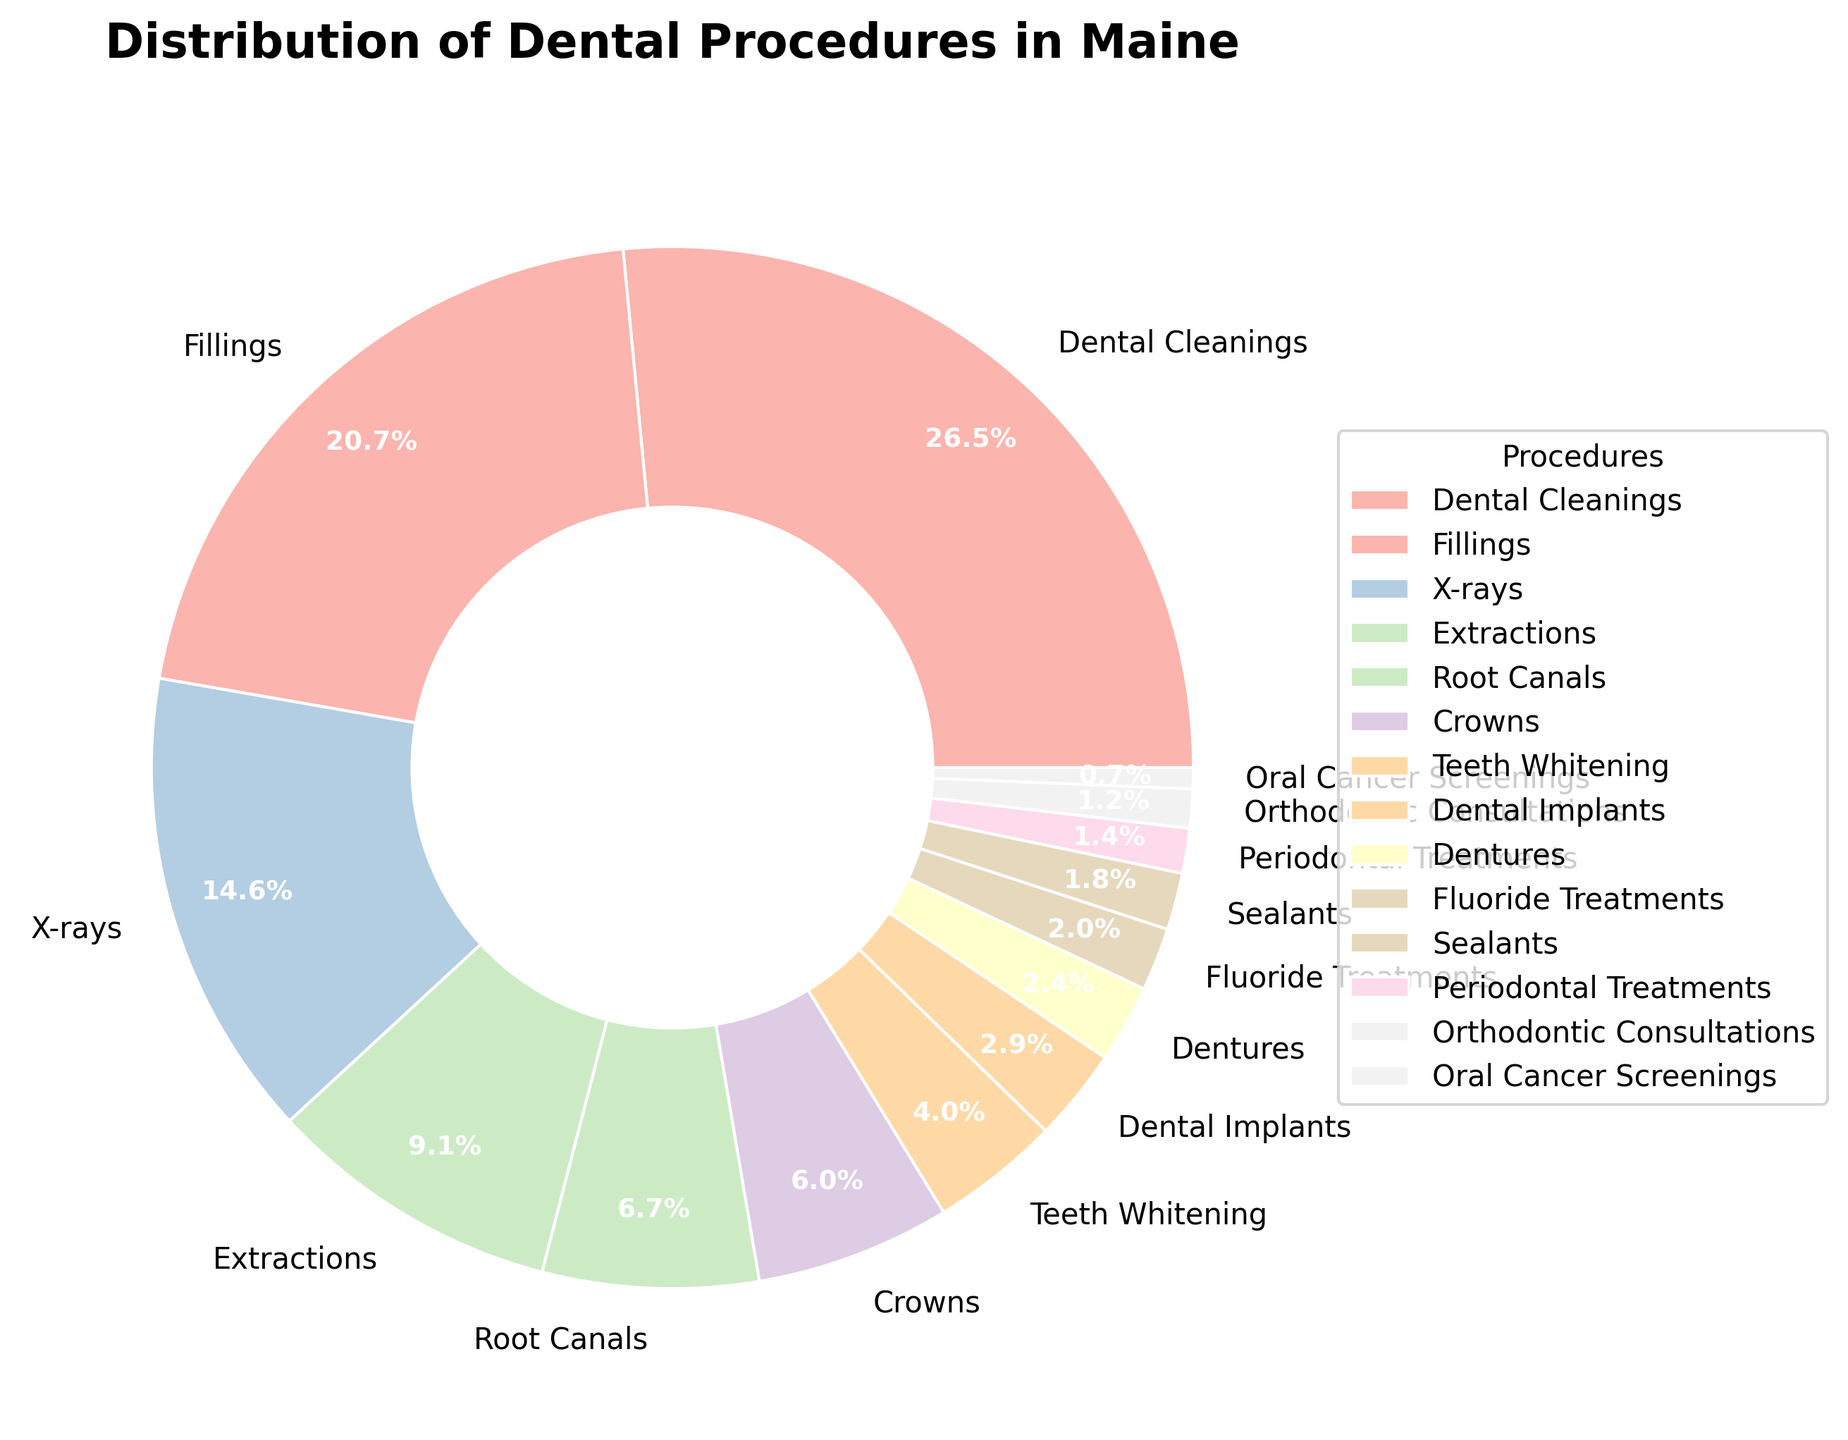What's the most common dental procedure in Maine? The figure shows the distributions of different dental procedures in Maine based on their percentages. By looking at the wedge with the largest percentage, we can identify the most common procedure. The largest wedge corresponds to Dental Cleanings, which has a percentage of 28.5%.
Answer: Dental Cleanings What percentage of procedures are Extractions compared to Fillings? To answer this question, we need to locate the wedges representing Extractions and Fillings in the pie chart. Extractions account for 9.8%, and Fillings account for 22.3%. Comparing these two percentages, Extracts are less frequent than Fillings.
Answer: Less frequent How do the combined percentages of Dental Cleanings and Fillings compare to all other procedures? First, sum the percentages of Dental Cleanings (28.5%) and Fillings (22.3%), which equals 50.8%. Then, compare this to the sum of the remaining procedures, which is 100% - 50.8% = 49.2%. Dental Cleanings and Fillings together are performed more frequently than all other procedures combined.
Answer: More frequent Which procedures together make up more than half of all procedures? We need to find combinations of procedures that together account for more than 50% of the total. Starting with the largest percentages: Dental Cleanings (28.5%) and Fillings (22.3%) together add up to 50.8%. Therefore, these two procedures alone make up more than half of all procedures.
Answer: Dental Cleanings and Fillings How much more common are Dental Cleanings compared to Fluoride Treatments? Locate the percentages for Dental Cleanings (28.5%) and Fluoride Treatments (2.1%) on the pie chart. Calculate the difference: 28.5% - 2.1% = 26.4%. Dental Cleanings are 26.4% more common than Fluoride Treatments.
Answer: 26.4% What is the least common dental procedure shown in the chart? Identify the smallest wedge in the pie chart, which corresponds to the procedure with the lowest percentage. The smallest wedge is for Oral Cancer Screenings, with a percentage of 0.7%.
Answer: Oral Cancer Screenings What total percentage do the Orthodontic Consultations and Periodontal Treatments represent together? Add the percentages of Orthodontic Consultations (1.3%) and Periodontal Treatments (1.5%). The total percentage is 1.3% + 1.5% = 2.8%.
Answer: 2.8% Are Root Canals more common than Crowns? Compare the percentages of Root Canals (7.2%) and Crowns (6.5%) as shown in the pie chart. Root Canals have a higher percentage than Crowns.
Answer: Yes What is the percentage difference between X-rays and Dental Implants? Find the percentages for X-rays (15.7%) and Dental Implants (3.1%) on the chart. Subtract the smaller percentage from the larger one: 15.7% - 3.1% = 12.6%. The percentage difference between X-rays and Dental Implants is 12.6%.
Answer: 12.6% Which dental procedure category has a visually significant light pink portion of the pie chart? Without specific colors, you would look for the Pastel1 color scheme generally associated with certain colors for certain procedures. In this context, since exact colors were not specified, refer back to the dataframe and the corresponding chart. Visually, you might find the light-pink portion around the sections described.
Answer: Interpretation based on color scheme needed 